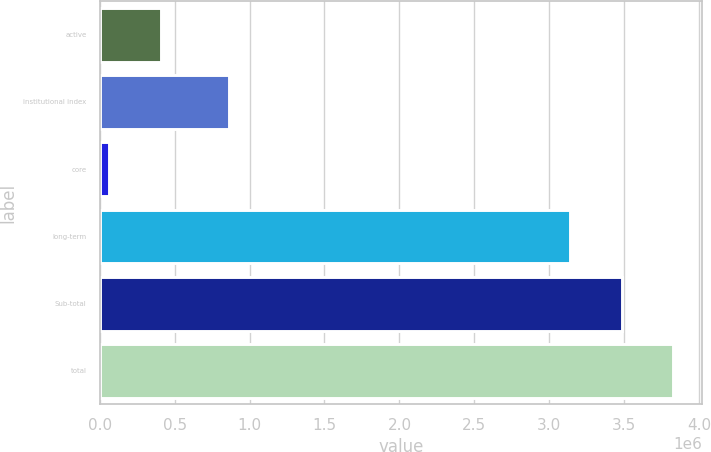Convert chart to OTSL. <chart><loc_0><loc_0><loc_500><loc_500><bar_chart><fcel>active<fcel>institutional index<fcel>core<fcel>long-term<fcel>Sub-total<fcel>total<nl><fcel>408550<fcel>865299<fcel>63647<fcel>3.13795e+06<fcel>3.48285e+06<fcel>3.82775e+06<nl></chart> 